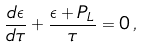Convert formula to latex. <formula><loc_0><loc_0><loc_500><loc_500>\frac { d \epsilon } { d \tau } + \frac { \epsilon + P _ { L } } { \tau } = 0 \, ,</formula> 